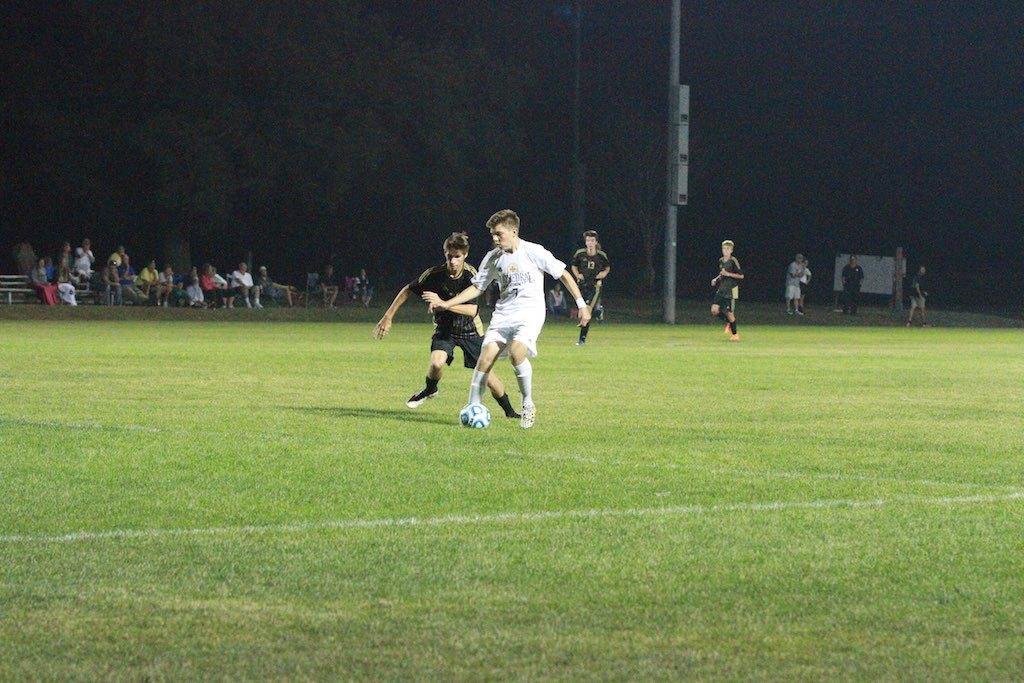In one or two sentences, can you explain what this image depicts? This picture is taken in football ground, There is grass on the ground and there are some people playing the football and in the background there are some people sitting on the chairs and there are some green color trees. 